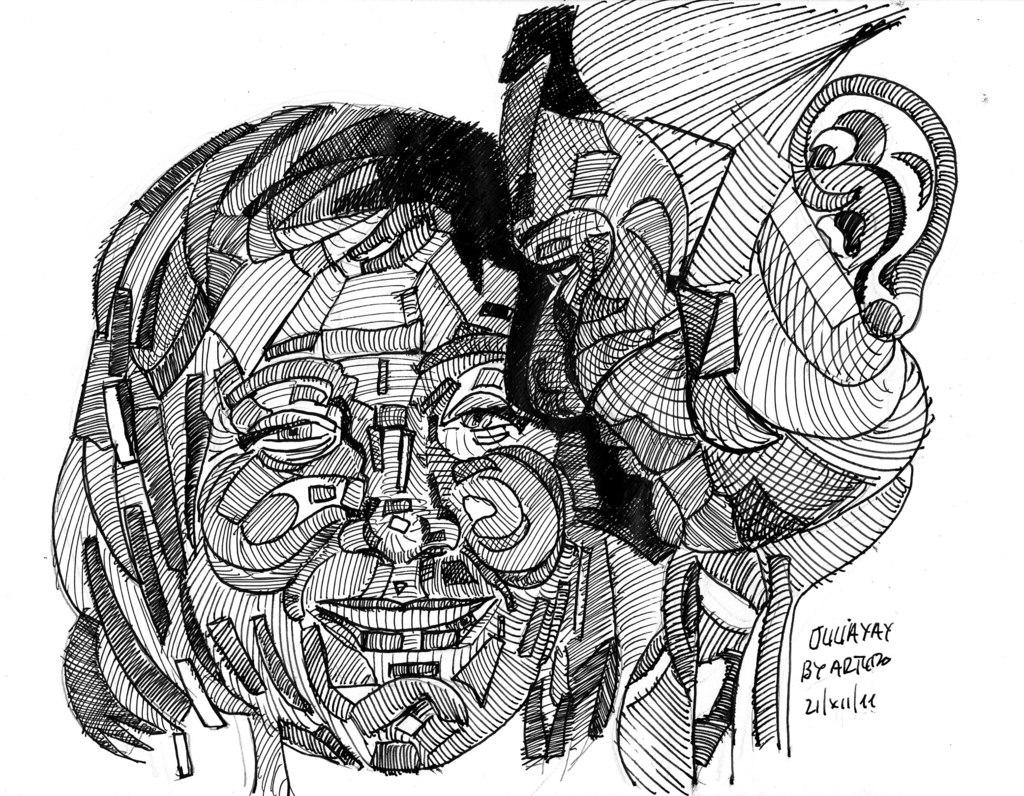What is the main subject in the middle of the image? There is a painting in the middle of the image. Can you describe any additional details about the painting? Unfortunately, the provided facts do not offer any additional details about the painting. Is there any text visible in the image? Yes, there is written text at the bottom right corner of the image. What type of sack is being carried by the minister in the image? There is no minister or sack present in the image; it only features a painting and written text. 